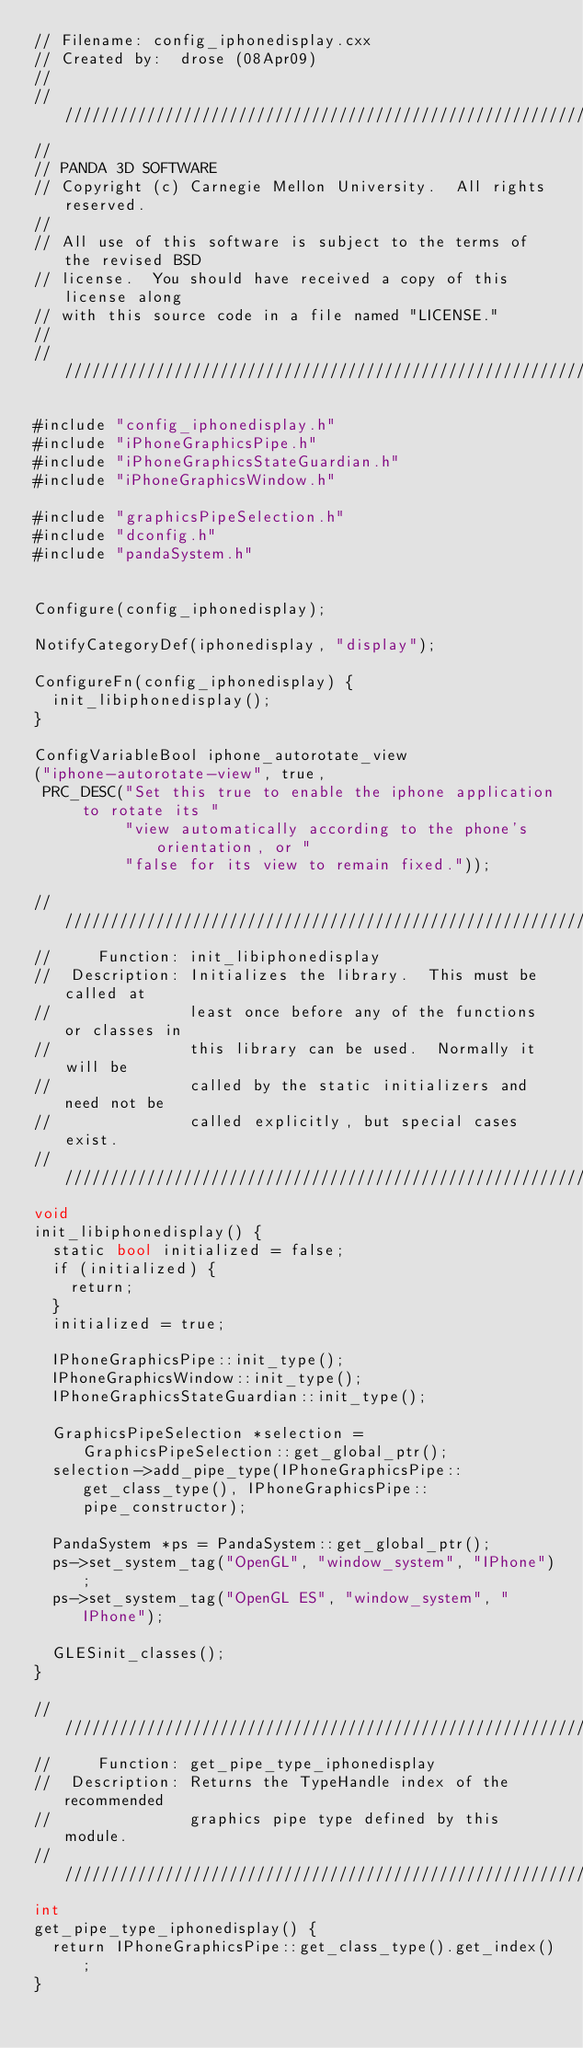<code> <loc_0><loc_0><loc_500><loc_500><_ObjectiveC_>// Filename: config_iphonedisplay.cxx
// Created by:  drose (08Apr09)
//
////////////////////////////////////////////////////////////////////
//
// PANDA 3D SOFTWARE
// Copyright (c) Carnegie Mellon University.  All rights reserved.
//
// All use of this software is subject to the terms of the revised BSD
// license.  You should have received a copy of this license along
// with this source code in a file named "LICENSE."
//
////////////////////////////////////////////////////////////////////

#include "config_iphonedisplay.h"
#include "iPhoneGraphicsPipe.h"
#include "iPhoneGraphicsStateGuardian.h"
#include "iPhoneGraphicsWindow.h"

#include "graphicsPipeSelection.h"
#include "dconfig.h"
#include "pandaSystem.h"


Configure(config_iphonedisplay);

NotifyCategoryDef(iphonedisplay, "display");

ConfigureFn(config_iphonedisplay) {
  init_libiphonedisplay();
}

ConfigVariableBool iphone_autorotate_view
("iphone-autorotate-view", true,
 PRC_DESC("Set this true to enable the iphone application to rotate its "
          "view automatically according to the phone's orientation, or "
          "false for its view to remain fixed."));

////////////////////////////////////////////////////////////////////
//     Function: init_libiphonedisplay
//  Description: Initializes the library.  This must be called at
//               least once before any of the functions or classes in
//               this library can be used.  Normally it will be
//               called by the static initializers and need not be
//               called explicitly, but special cases exist.
////////////////////////////////////////////////////////////////////
void
init_libiphonedisplay() {
  static bool initialized = false;
  if (initialized) {
    return;
  }
  initialized = true;

  IPhoneGraphicsPipe::init_type();
  IPhoneGraphicsWindow::init_type();
  IPhoneGraphicsStateGuardian::init_type();

  GraphicsPipeSelection *selection = GraphicsPipeSelection::get_global_ptr();
  selection->add_pipe_type(IPhoneGraphicsPipe::get_class_type(), IPhoneGraphicsPipe::pipe_constructor);

  PandaSystem *ps = PandaSystem::get_global_ptr();
  ps->set_system_tag("OpenGL", "window_system", "IPhone");
  ps->set_system_tag("OpenGL ES", "window_system", "IPhone");

  GLESinit_classes();
}

////////////////////////////////////////////////////////////////////
//     Function: get_pipe_type_iphonedisplay
//  Description: Returns the TypeHandle index of the recommended
//               graphics pipe type defined by this module.
////////////////////////////////////////////////////////////////////
int
get_pipe_type_iphonedisplay() {
  return IPhoneGraphicsPipe::get_class_type().get_index();
}
</code> 